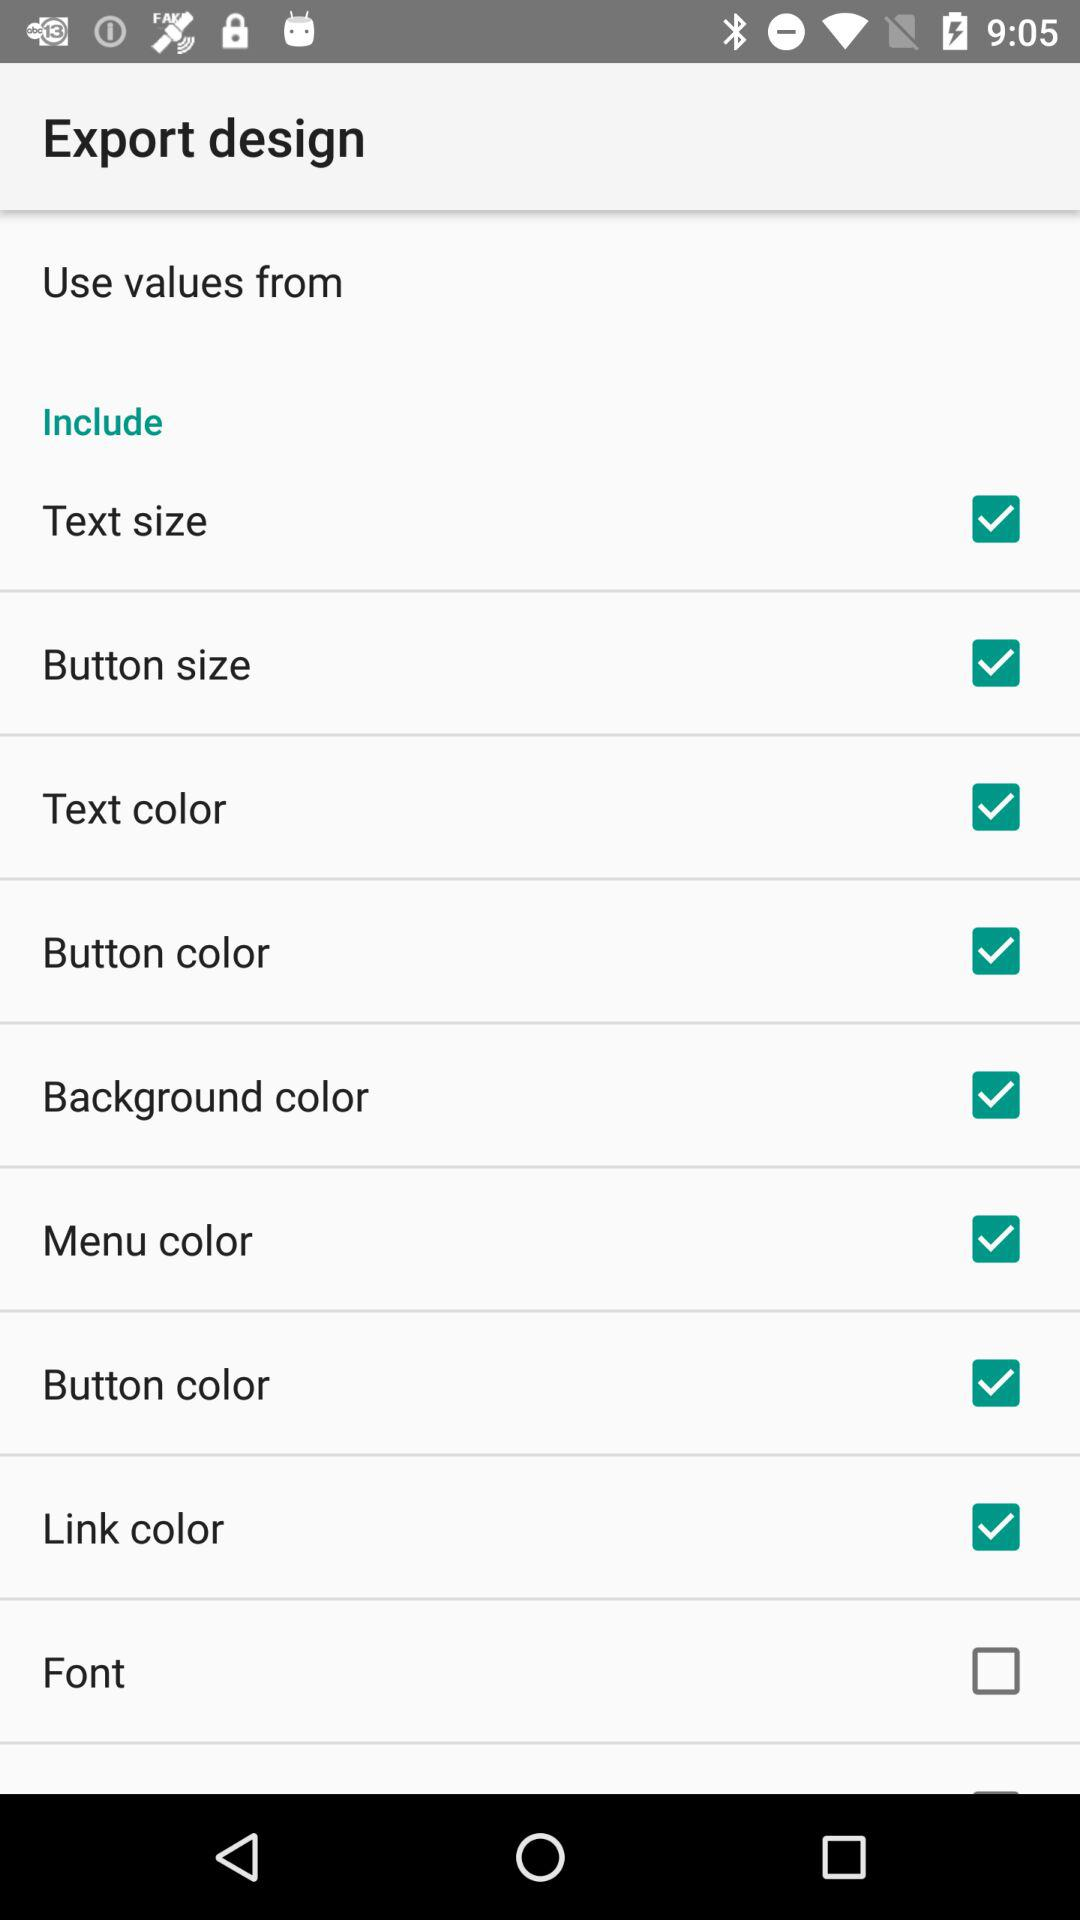What is the status of the "Text size"? The status is "on". 